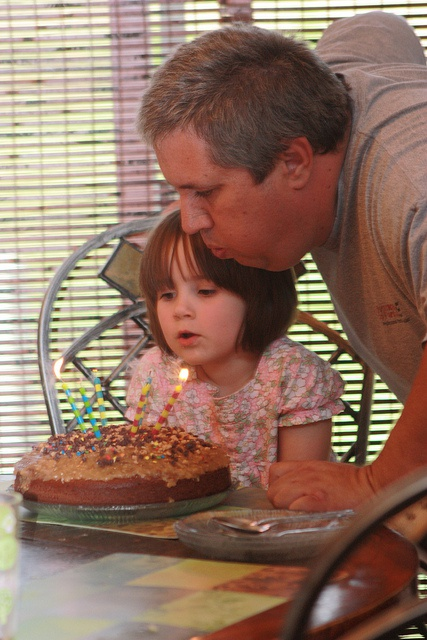Describe the objects in this image and their specific colors. I can see people in beige, maroon, gray, brown, and black tones, dining table in beige, maroon, darkgray, brown, and tan tones, people in beige, brown, maroon, and black tones, chair in beige, darkgray, khaki, and gray tones, and chair in beige, maroon, black, brown, and gray tones in this image. 